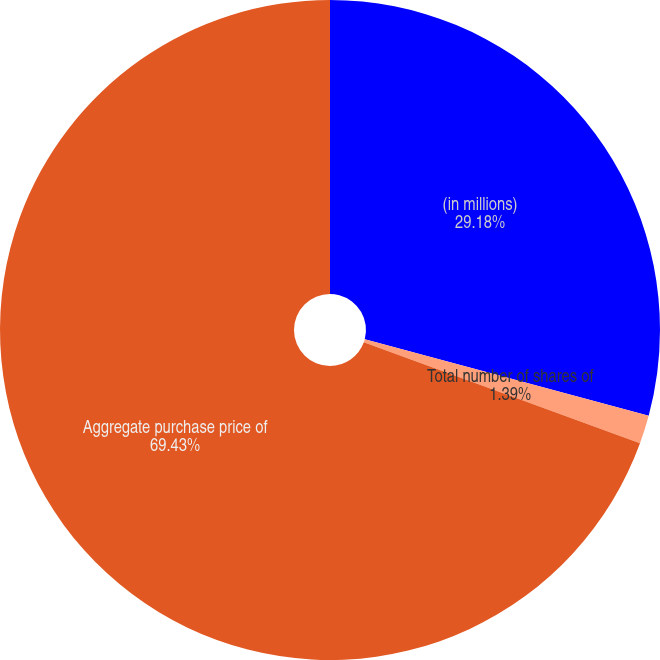Convert chart. <chart><loc_0><loc_0><loc_500><loc_500><pie_chart><fcel>(in millions)<fcel>Total number of shares of<fcel>Aggregate purchase price of<nl><fcel>29.18%<fcel>1.39%<fcel>69.43%<nl></chart> 